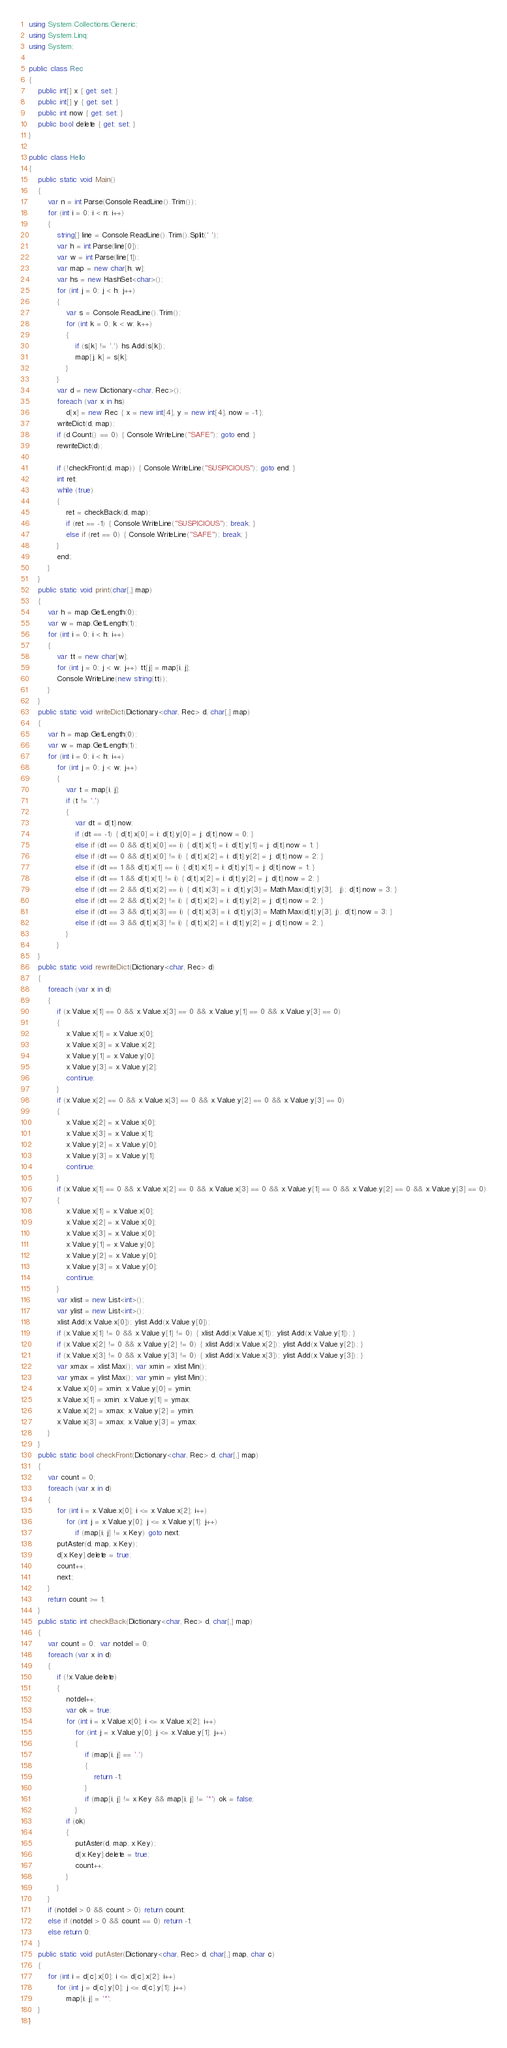Convert code to text. <code><loc_0><loc_0><loc_500><loc_500><_C#_>using System.Collections.Generic;
using System.Linq;
using System;

public class Rec
{
    public int[] x { get; set; }
    public int[] y { get; set; }
    public int now { get; set; }
    public bool delete { get; set; }
}

public class Hello
{
    public static void Main()
    {
        var n = int.Parse(Console.ReadLine().Trim());
        for (int i = 0; i < n; i++)
        {
            string[] line = Console.ReadLine().Trim().Split(' ');
            var h = int.Parse(line[0]);
            var w = int.Parse(line[1]);
            var map = new char[h, w];
            var hs = new HashSet<char>();
            for (int j = 0; j < h; j++)
            {
                var s = Console.ReadLine().Trim();
                for (int k = 0; k < w; k++)
                {
                    if (s[k] != '.') hs.Add(s[k]);
                    map[j, k] = s[k];
                }
            }
            var d = new Dictionary<char, Rec>();
            foreach (var x in hs)
                d[x] = new Rec { x = new int[4], y = new int[4], now = -1 };
            writeDict(d, map);
            if (d.Count() == 0) { Console.WriteLine("SAFE"); goto end; }
            rewriteDict(d);

            if (!checkFront(d, map)) { Console.WriteLine("SUSPICIOUS"); goto end; }
            int ret;
            while (true)
            {
                ret = checkBack(d, map);
                if (ret == -1) { Console.WriteLine("SUSPICIOUS"); break; }
                else if (ret == 0) { Console.WriteLine("SAFE"); break; }
            }
            end:;
        }
    }
    public static void print(char[,] map)
    {
        var h = map.GetLength(0);
        var w = map.GetLength(1);
        for (int i = 0; i < h; i++)
        {
            var tt = new char[w];
            for (int j = 0; j < w; j++) tt[j] = map[i, j];
            Console.WriteLine(new string(tt));
        }
    }
    public static void writeDict(Dictionary<char, Rec> d, char[,] map)
    {
        var h = map.GetLength(0);
        var w = map.GetLength(1);
        for (int i = 0; i < h; i++)
            for (int j = 0; j < w; j++)
            {
                var t = map[i, j];
                if (t != '.')
                {
                    var dt = d[t].now;
                    if (dt == -1) { d[t].x[0] = i; d[t].y[0] = j; d[t].now = 0; }
                    else if (dt == 0 && d[t].x[0] == i) { d[t].x[1] = i; d[t].y[1] = j; d[t].now = 1; }
                    else if (dt == 0 && d[t].x[0] != i) { d[t].x[2] = i; d[t].y[2] = j; d[t].now = 2; }
                    else if (dt == 1 && d[t].x[1] == i) { d[t].x[1] = i; d[t].y[1] = j; d[t].now = 1; }
                    else if (dt == 1 && d[t].x[1] != i) { d[t].x[2] = i; d[t].y[2] = j; d[t].now = 2; }
                    else if (dt == 2 && d[t].x[2] == i) { d[t].x[3] = i; d[t].y[3] = Math.Max(d[t].y[3],   j); d[t].now = 3; }
                    else if (dt == 2 && d[t].x[2] != i) { d[t].x[2] = i; d[t].y[2] = j; d[t].now = 2; }
                    else if (dt == 3 && d[t].x[3] == i) { d[t].x[3] = i; d[t].y[3] = Math.Max(d[t].y[3], j); d[t].now = 3; }
                    else if (dt == 3 && d[t].x[3] != i) { d[t].x[2] = i; d[t].y[2] = j; d[t].now = 2; }
                }
            }
    }
    public static void rewriteDict(Dictionary<char, Rec> d)
    {
        foreach (var x in d)
        {
            if (x.Value.x[1] == 0 && x.Value.x[3] == 0 && x.Value.y[1] == 0 && x.Value.y[3] == 0)
            {
                x.Value.x[1] = x.Value.x[0];
                x.Value.x[3] = x.Value.x[2];
                x.Value.y[1] = x.Value.y[0];
                x.Value.y[3] = x.Value.y[2];
                continue;
            }
            if (x.Value.x[2] == 0 && x.Value.x[3] == 0 && x.Value.y[2] == 0 && x.Value.y[3] == 0)
            {
                x.Value.x[2] = x.Value.x[0];
                x.Value.x[3] = x.Value.x[1];
                x.Value.y[2] = x.Value.y[0];
                x.Value.y[3] = x.Value.y[1];
                continue;
            }
            if (x.Value.x[1] == 0 && x.Value.x[2] == 0 && x.Value.x[3] == 0 && x.Value.y[1] == 0 && x.Value.y[2] == 0 && x.Value.y[3] == 0)
            {
                x.Value.x[1] = x.Value.x[0];
                x.Value.x[2] = x.Value.x[0];
                x.Value.x[3] = x.Value.x[0];
                x.Value.y[1] = x.Value.y[0];
                x.Value.y[2] = x.Value.y[0];
                x.Value.y[3] = x.Value.y[0];
                continue;
            }
            var xlist = new List<int>();
            var ylist = new List<int>();
            xlist.Add(x.Value.x[0]); ylist.Add(x.Value.y[0]);
            if (x.Value.x[1] != 0 && x.Value.y[1] != 0) { xlist.Add(x.Value.x[1]); ylist.Add(x.Value.y[1]); }
            if (x.Value.x[2] != 0 && x.Value.y[2] != 0) { xlist.Add(x.Value.x[2]); ylist.Add(x.Value.y[2]); }
            if (x.Value.x[3] != 0 && x.Value.y[3] != 0) { xlist.Add(x.Value.x[3]); ylist.Add(x.Value.y[3]); }
            var xmax = xlist.Max(); var xmin = xlist.Min();
            var ymax = ylist.Max(); var ymin = ylist.Min();
            x.Value.x[0] = xmin; x.Value.y[0] = ymin;
            x.Value.x[1] = xmin; x.Value.y[1] = ymax;
            x.Value.x[2] = xmax; x.Value.y[2] = ymin;
            x.Value.x[3] = xmax; x.Value.y[3] = ymax;
        }
    }
    public static bool checkFront(Dictionary<char, Rec> d, char[,] map)
    {
        var count = 0;
        foreach (var x in d)
        {
            for (int i = x.Value.x[0]; i <= x.Value.x[2]; i++)
                for (int j = x.Value.y[0]; j <= x.Value.y[1]; j++)
                    if (map[i, j] != x.Key) goto next;
            putAster(d, map, x.Key);
            d[x.Key].delete = true;
            count++;
            next:;
        }
        return count >= 1;
    }
    public static int checkBack(Dictionary<char, Rec> d, char[,] map)
    {
        var count = 0;  var notdel = 0;
        foreach (var x in d)
        {
            if (!x.Value.delete)
            {
                notdel++;
                var ok = true;
                for (int i = x.Value.x[0]; i <= x.Value.x[2]; i++)
                    for (int j = x.Value.y[0]; j <= x.Value.y[1]; j++)
                    {
                        if (map[i, j] == '.')
                        {
                            return -1;
                        }
                        if (map[i, j] != x.Key && map[i, j] != '*') ok = false;
                    }
                if (ok)
                {
                    putAster(d, map, x.Key);
                    d[x.Key].delete = true;
                    count++;
                }
            }
        }
        if (notdel > 0 && count > 0) return count;
        else if (notdel > 0 && count == 0) return -1;
        else return 0;
    }
    public static void putAster(Dictionary<char, Rec> d, char[,] map, char c)
    {
        for (int i = d[c].x[0]; i <= d[c].x[2]; i++)
            for (int j = d[c].y[0]; j <= d[c].y[1]; j++)
                map[i, j] = '*';
    }
}


</code> 